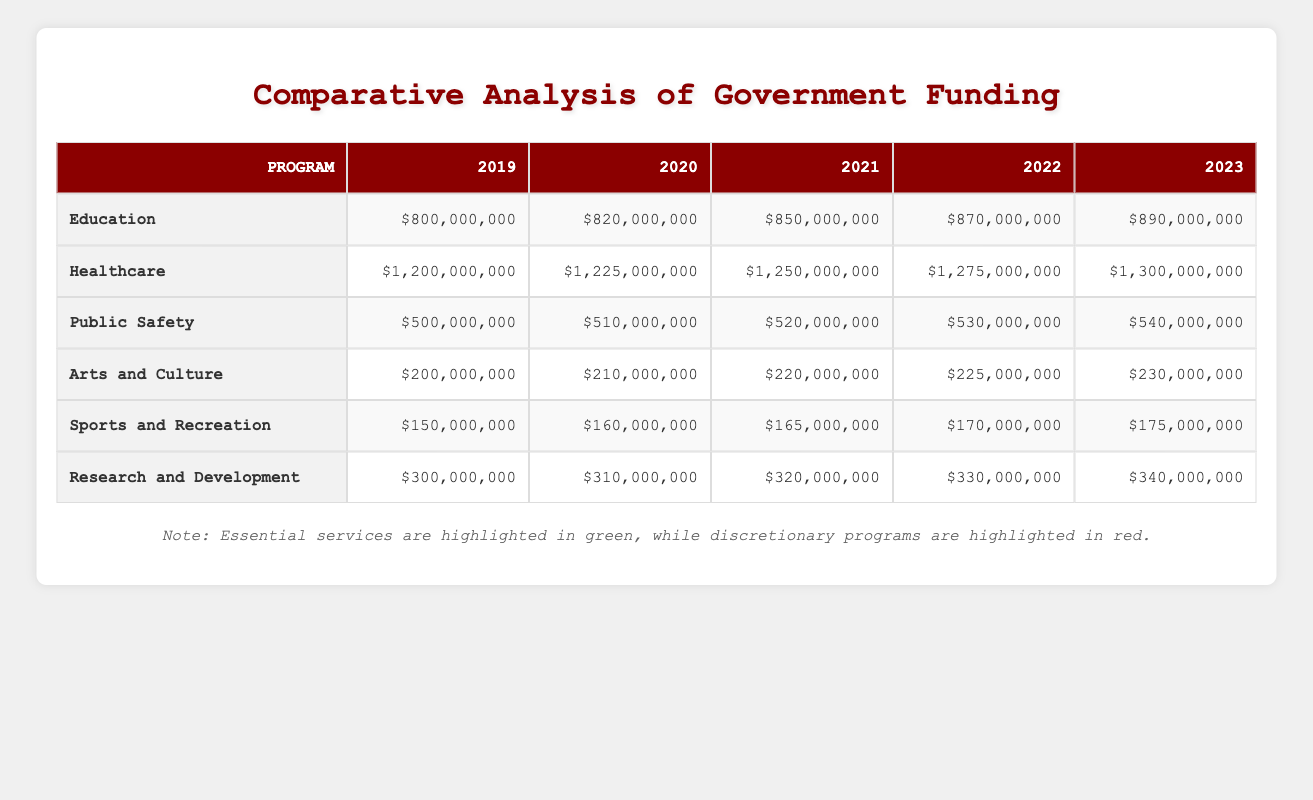What was the funding for Healthcare in 2022? The table shows the value for Healthcare in the year 2022 is $1,275,000,000.
Answer: $1,275,000,000 What is the total funding for all Essential Services in 2023? To find the total funding for Essential Services in 2023, we sum the values: $890,000,000 (Education) + $1,300,000,000 (Healthcare) + $540,000,000 (Public Safety) = $2,730,000,000.
Answer: $2,730,000,000 Is the funding for Public Safety in 2020 greater than the funding for Arts and Culture in the same year? The funding for Public Safety in 2020 is $510,000,000, while the funding for Arts and Culture in 2020 is $210,000,000. Since $510,000,000 is greater than $210,000,000, the statement is true.
Answer: Yes What was the increase in funding for Research and Development from 2019 to 2023? The funding for Research and Development in 2019 was $300,000,000 and in 2023 it was $340,000,000. The increase is calculated as $340,000,000 - $300,000,000 = $40,000,000.
Answer: $40,000,000 Which program had the highest funding level in 2021? The table shows that Healthcare had the highest funding level in 2021 with $1,250,000,000. Other programs had lower funding levels: Education had $850,000,000, Public Safety had $520,000,000, Arts and Culture had $220,000,000, Sports and Recreation had $165,000,000, and Research and Development had $320,000,000.
Answer: Healthcare What is the average annual funding for Sports and Recreation across the years 2019-2023? The funding levels for Sports and Recreation are: $150,000,000 (2019), $160,000,000 (2020), $165,000,000 (2021), $170,000,000 (2022), and $175,000,000 (2023). The total funding is $150,000,000 + $160,000,000 + $165,000,000 + $170,000,000 + $175,000,000 = $820,000,000. The average is $820,000,000 / 5 = $164,000,000.
Answer: $164,000,000 Did the funding for Essential Services rise in every year from 2019 to 2023? By analyzing the data for each year, we can see that the funding for Education, Healthcare, and Public Safety all increased year-over-year for each of the years from 2019 to 2023. Therefore, the statement is true.
Answer: Yes What is the combined funding for all Discretionary Programs in 2022? We need to sum the funding levels for Arts and Culture, Sports and Recreation, and Research and Development in 2022. The values are: $225,000,000 (Arts and Culture) + $170,000,000 (Sports and Recreation) + $330,000,000 (Research and Development). The combined total is $225,000,000 + $170,000,000 + $330,000,000 = $725,000,000.
Answer: $725,000,000 